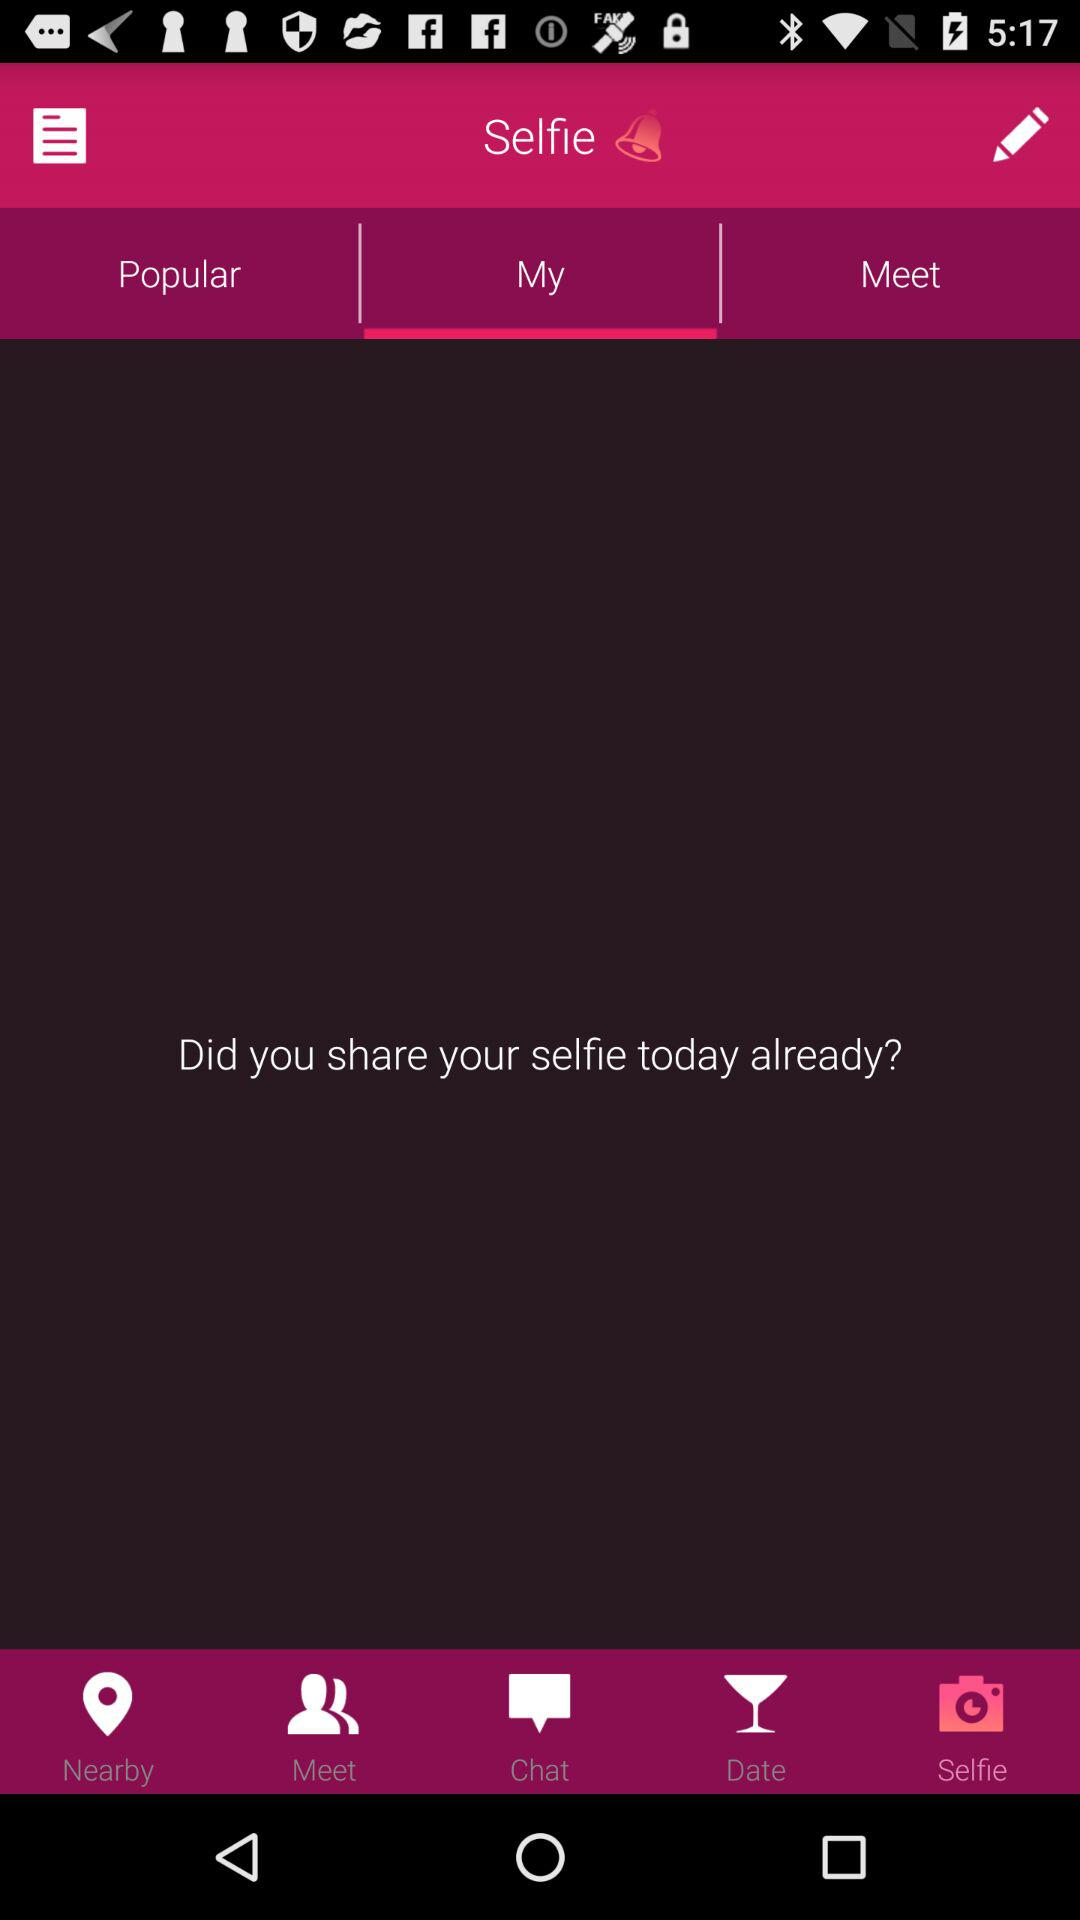What is the app's title? The app's title is "Selfie". 